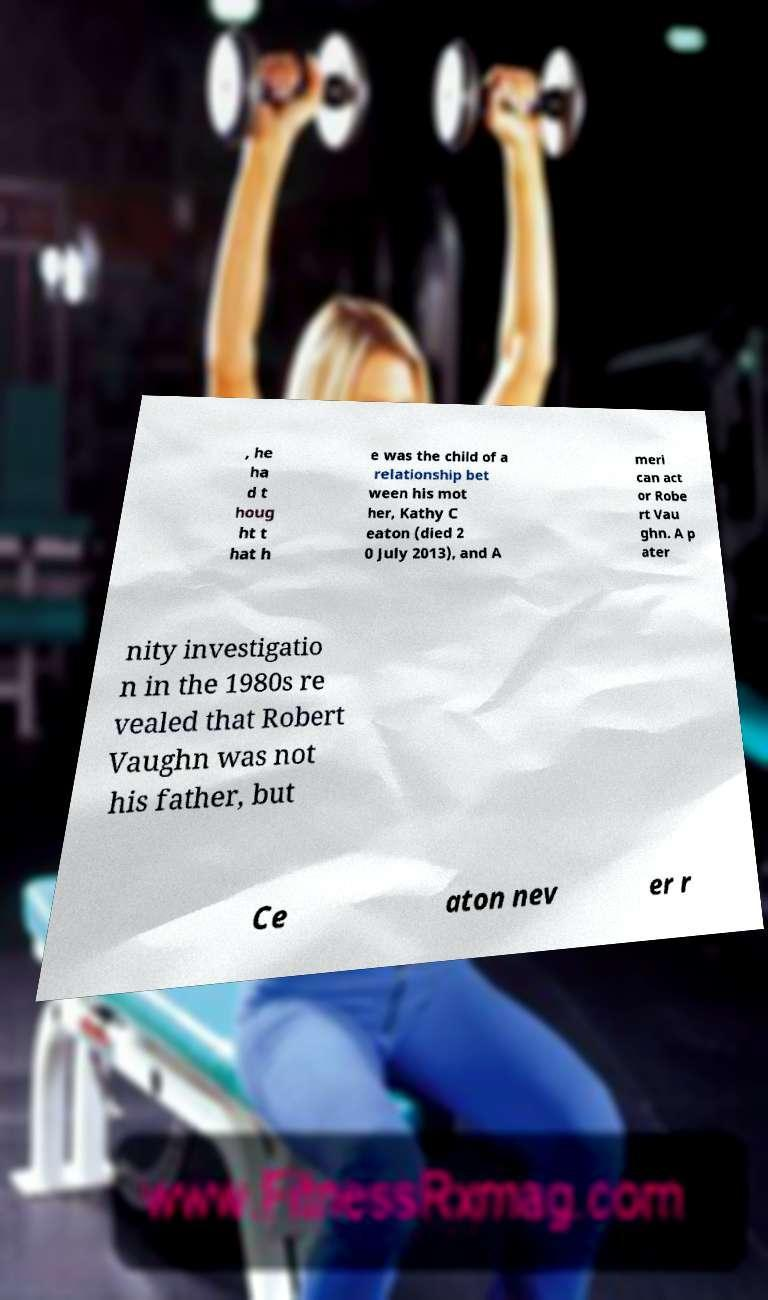Please read and relay the text visible in this image. What does it say? , he ha d t houg ht t hat h e was the child of a relationship bet ween his mot her, Kathy C eaton (died 2 0 July 2013), and A meri can act or Robe rt Vau ghn. A p ater nity investigatio n in the 1980s re vealed that Robert Vaughn was not his father, but Ce aton nev er r 